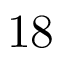<formula> <loc_0><loc_0><loc_500><loc_500>1 8</formula> 